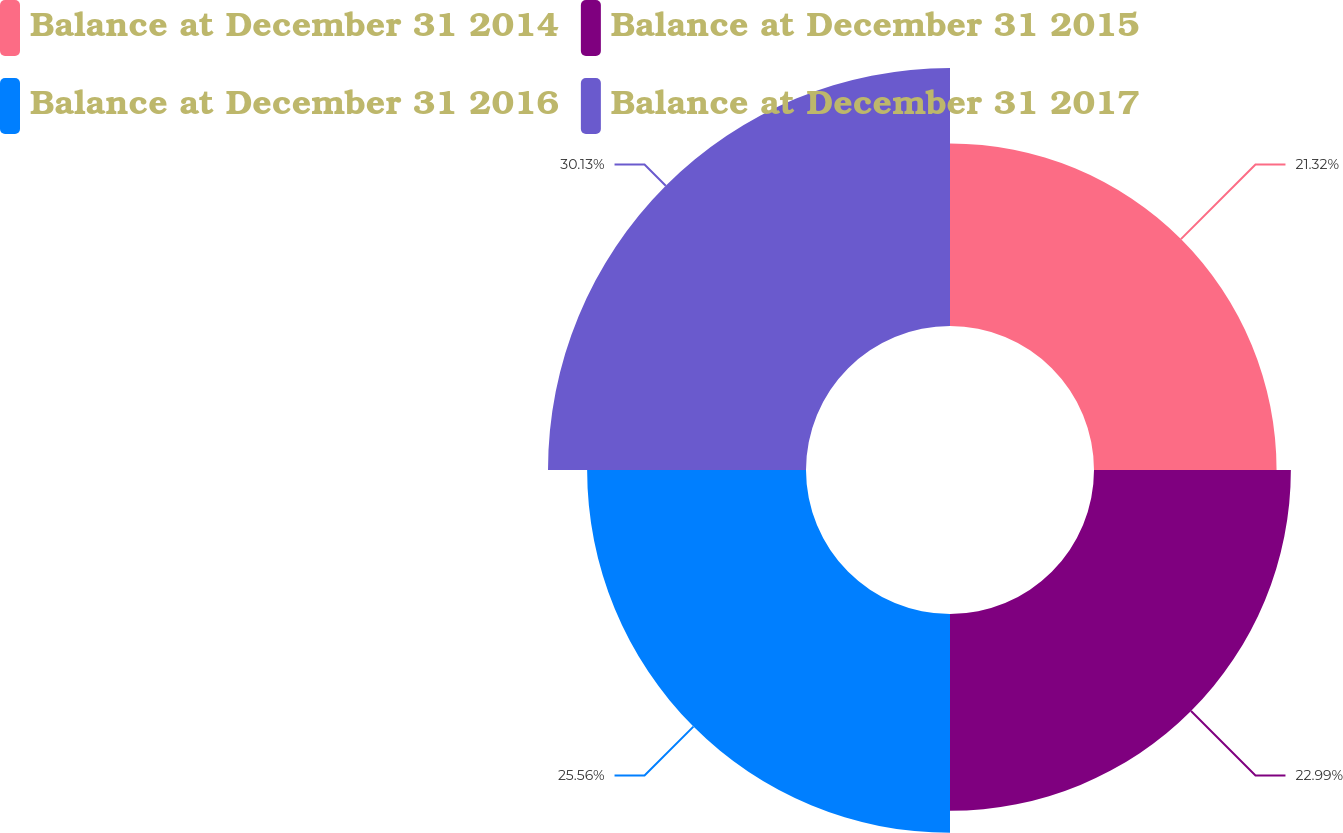Convert chart to OTSL. <chart><loc_0><loc_0><loc_500><loc_500><pie_chart><fcel>Balance at December 31 2014<fcel>Balance at December 31 2015<fcel>Balance at December 31 2016<fcel>Balance at December 31 2017<nl><fcel>21.32%<fcel>22.99%<fcel>25.56%<fcel>30.13%<nl></chart> 